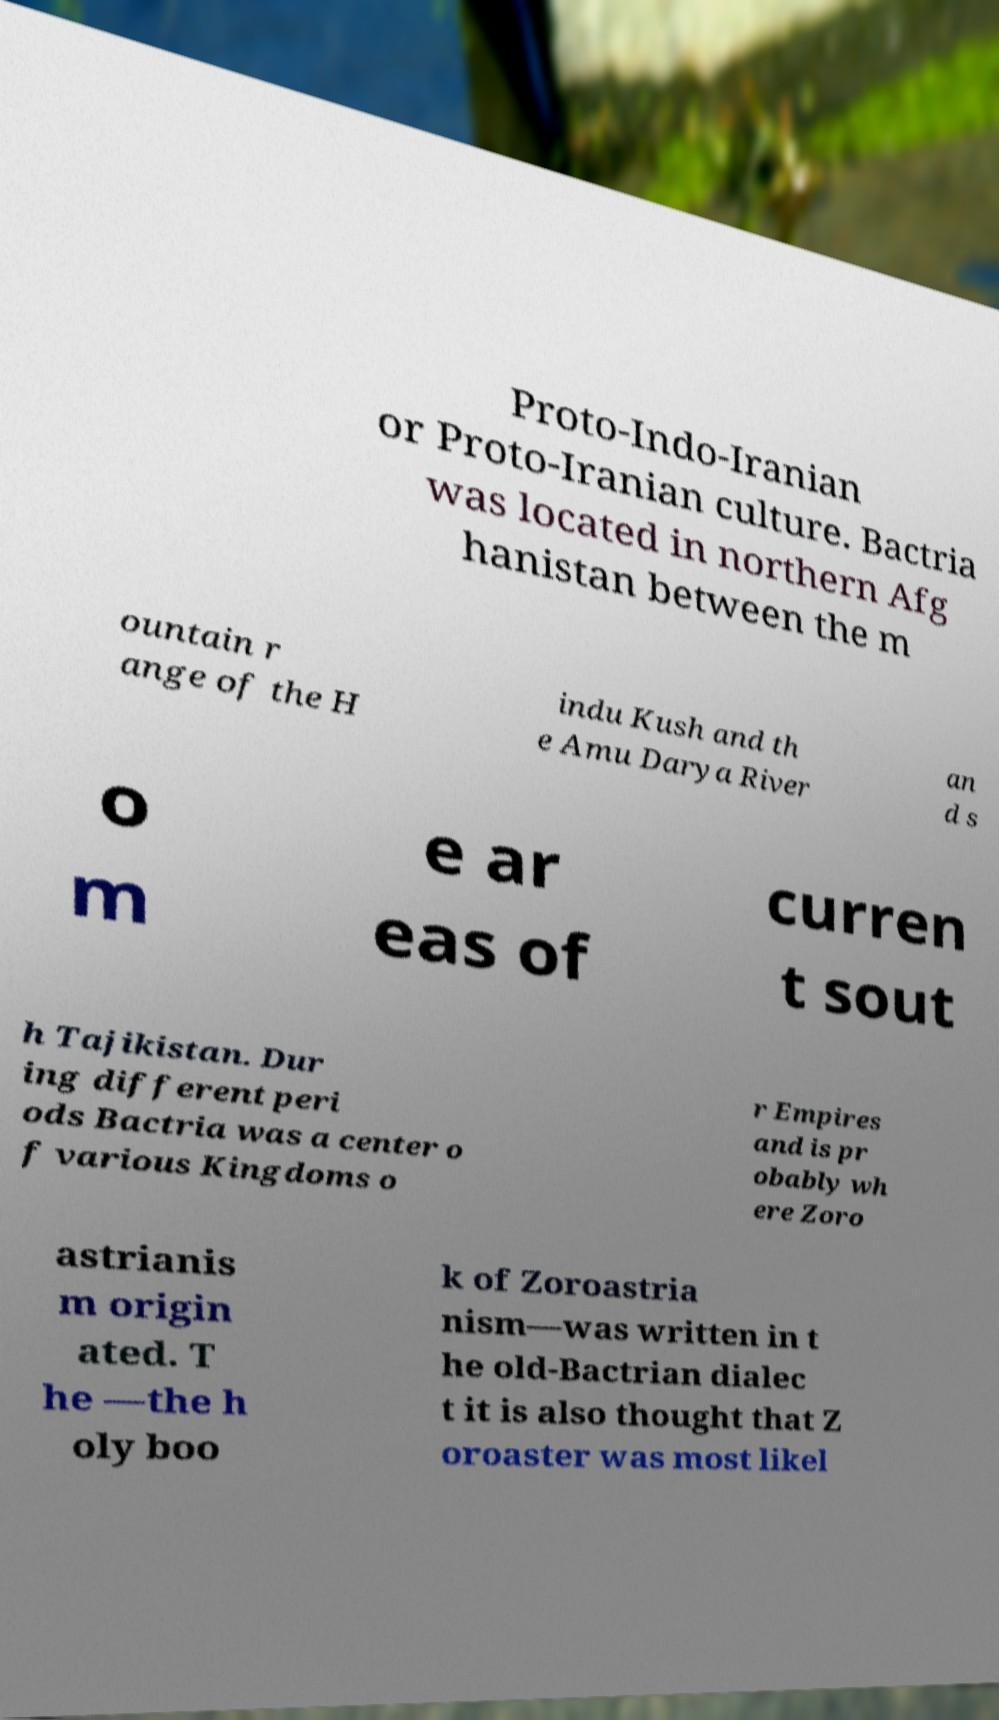Could you assist in decoding the text presented in this image and type it out clearly? Proto-Indo-Iranian or Proto-Iranian culture. Bactria was located in northern Afg hanistan between the m ountain r ange of the H indu Kush and th e Amu Darya River an d s o m e ar eas of curren t sout h Tajikistan. Dur ing different peri ods Bactria was a center o f various Kingdoms o r Empires and is pr obably wh ere Zoro astrianis m origin ated. T he —the h oly boo k of Zoroastria nism—was written in t he old-Bactrian dialec t it is also thought that Z oroaster was most likel 